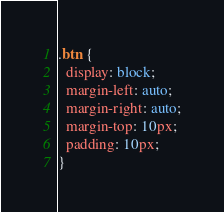<code> <loc_0><loc_0><loc_500><loc_500><_CSS_>.btn {
  display: block;
  margin-left: auto;
  margin-right: auto;
  margin-top: 10px;
  padding: 10px;
}
</code> 